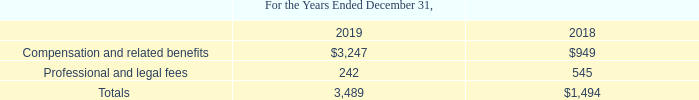Stock-Based Compensation
The Company accounts for options granted to employees by measuring the cost of services received in exchange for the award of equity instruments based upon the fair value of the award on the date of grant. The fair value of that award is then ratably recognized as an expense over the period during which the recipient is required to provide services in exchange for that award.
Options and warrants granted to consultants and other non-employees are recorded at fair value as of the grant date and subsequently adjusted to fair value at the end of each reporting period until such options and warrants vest, and the fair value of such instruments, as adjusted, is expensed over the related vesting period.
The Company measures the cost of services received in exchange for an award of equity instruments based on the fair value of the award. The fair value of the award is measured on the grant date and recognized over the period services are required to be provided in exchange for the award, usually the vesting period. Forfeitures of unvested stock options are recorded when they occur.
The Company incurred stock-based compensation charges of $3.5 million and $1.5 million for each of the years ended December 31, 2019 and 2018, respectively, which are included in general and administrative expenses. The following table summarizes the nature of such charges for the periods then ended (in thousands):
How does the company account for options granted to employees? By measuring the cost of services received in exchange for the award of equity instruments based upon the fair value of the award on the date of grant. How are options and warrants granted to consultants and other non-employees recorded? At fair value as of the grant date and subsequently adjusted to fair value at the end of each reporting period until such options and warrants vest, and the fair value of such instruments, as adjusted, is expensed over the related vesting period. What was the Compensation and related benefits in 2019 and 2018 respectively?
Answer scale should be: thousand. $3,247, $949. In which year was Professional and legal fees less than 500 thousands? Locate and analyze professional and legal fees in row 4
answer: 2019. What is the change in the Compensation and related benefits from 2018 to 2019?
Answer scale should be: thousand. 3,247 - 949
Answer: 2298. What was the average Professional and legal fees for 2018 and 2019?
Answer scale should be: thousand. (242 + 545) / 2
Answer: 393.5. 